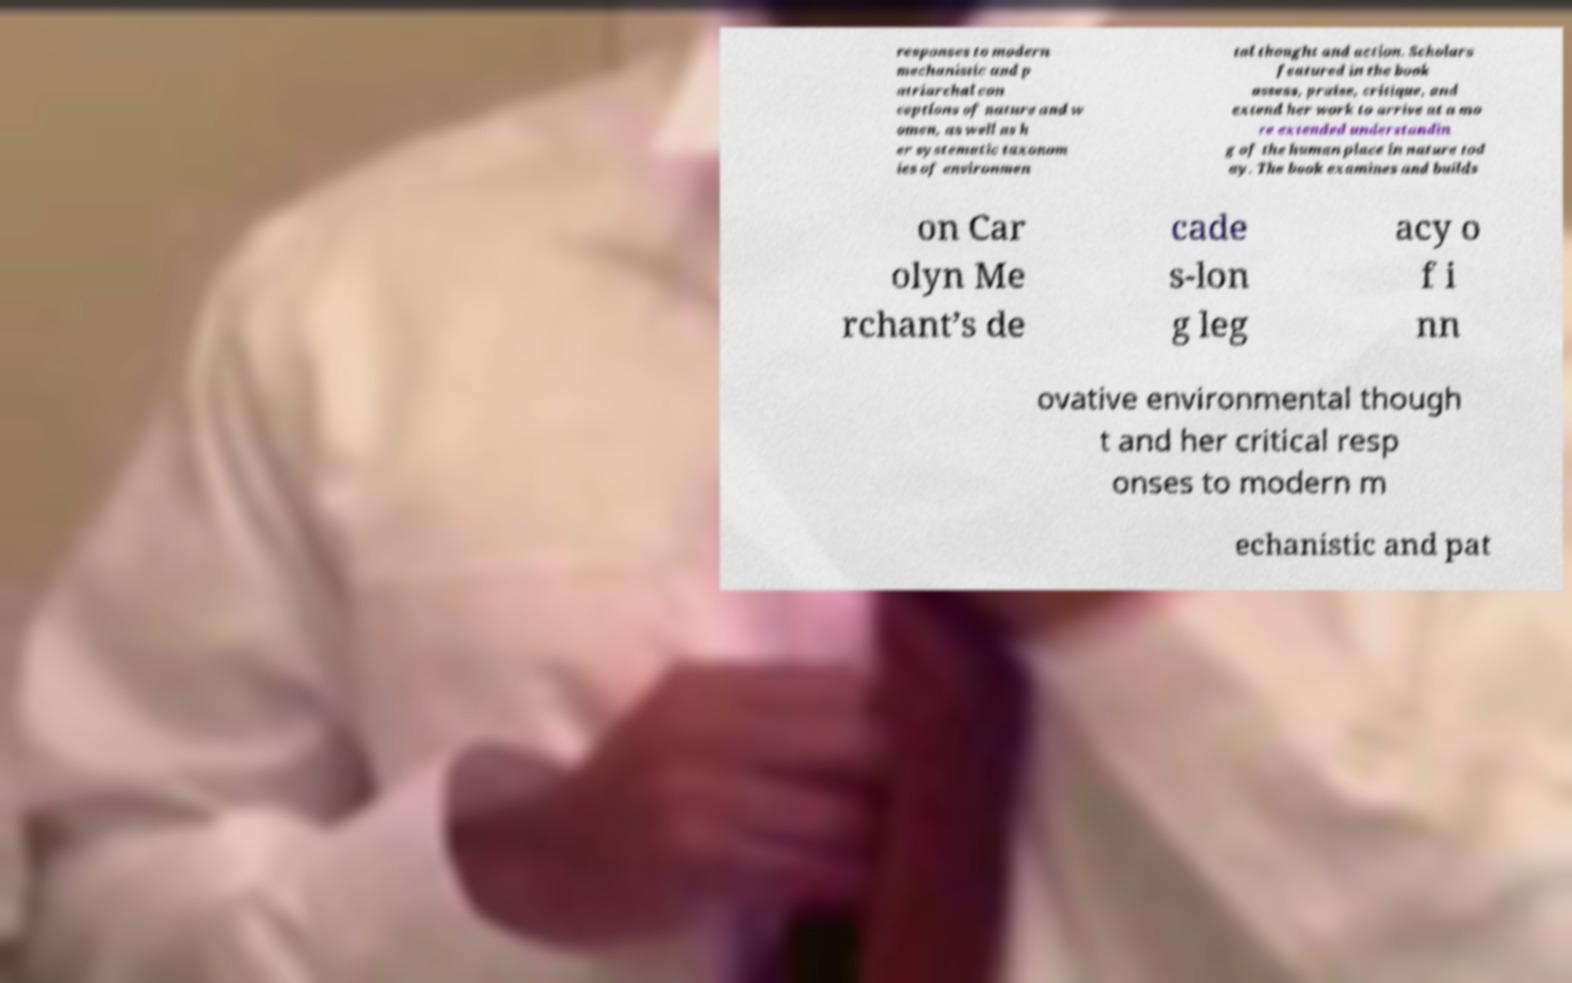There's text embedded in this image that I need extracted. Can you transcribe it verbatim? responses to modern mechanistic and p atriarchal con ceptions of nature and w omen, as well as h er systematic taxonom ies of environmen tal thought and action. Scholars featured in the book assess, praise, critique, and extend her work to arrive at a mo re extended understandin g of the human place in nature tod ay. The book examines and builds on Car olyn Me rchant’s de cade s-lon g leg acy o f i nn ovative environmental though t and her critical resp onses to modern m echanistic and pat 